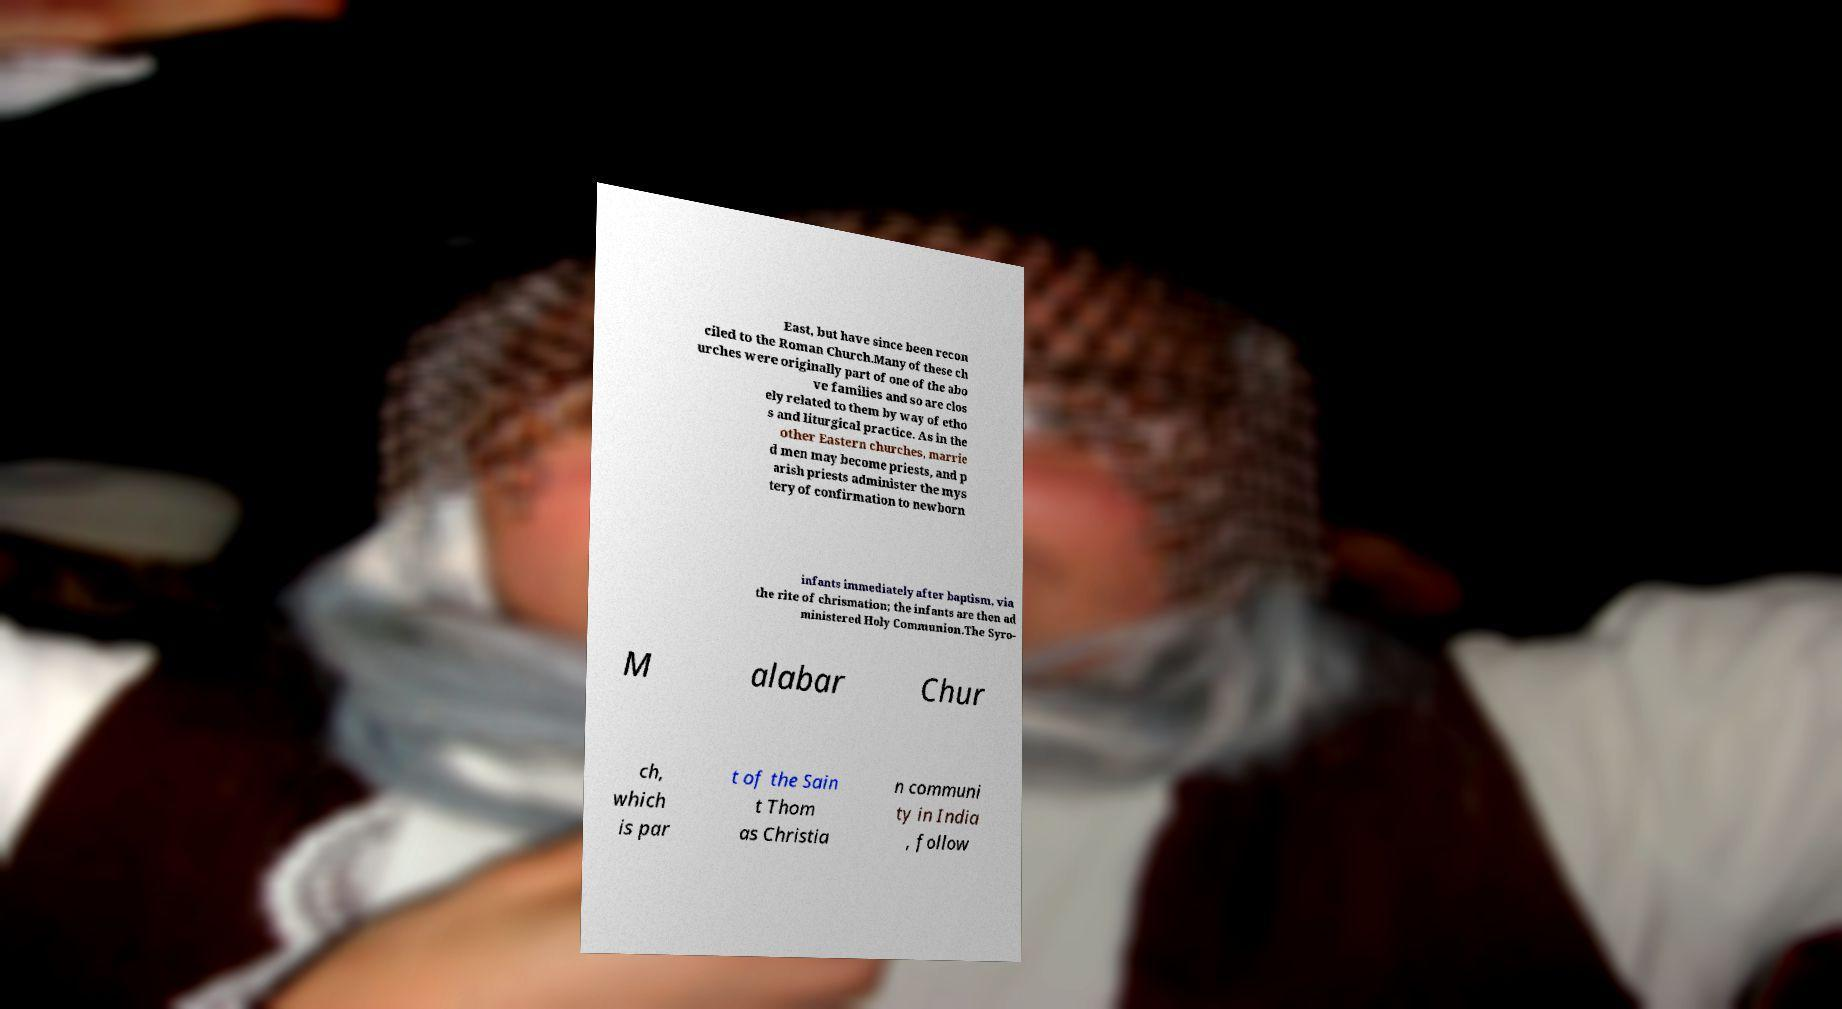There's text embedded in this image that I need extracted. Can you transcribe it verbatim? East, but have since been recon ciled to the Roman Church.Many of these ch urches were originally part of one of the abo ve families and so are clos ely related to them by way of etho s and liturgical practice. As in the other Eastern churches, marrie d men may become priests, and p arish priests administer the mys tery of confirmation to newborn infants immediately after baptism, via the rite of chrismation; the infants are then ad ministered Holy Communion.The Syro- M alabar Chur ch, which is par t of the Sain t Thom as Christia n communi ty in India , follow 